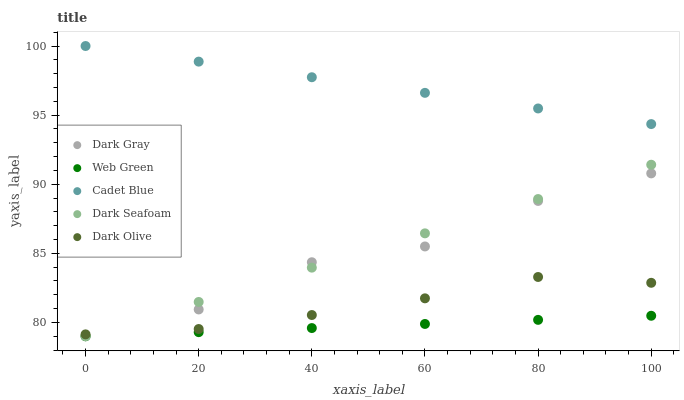Does Web Green have the minimum area under the curve?
Answer yes or no. Yes. Does Cadet Blue have the maximum area under the curve?
Answer yes or no. Yes. Does Dark Seafoam have the minimum area under the curve?
Answer yes or no. No. Does Dark Seafoam have the maximum area under the curve?
Answer yes or no. No. Is Dark Seafoam the smoothest?
Answer yes or no. Yes. Is Dark Gray the roughest?
Answer yes or no. Yes. Is Cadet Blue the smoothest?
Answer yes or no. No. Is Cadet Blue the roughest?
Answer yes or no. No. Does Dark Gray have the lowest value?
Answer yes or no. Yes. Does Cadet Blue have the lowest value?
Answer yes or no. No. Does Cadet Blue have the highest value?
Answer yes or no. Yes. Does Dark Seafoam have the highest value?
Answer yes or no. No. Is Web Green less than Cadet Blue?
Answer yes or no. Yes. Is Cadet Blue greater than Dark Gray?
Answer yes or no. Yes. Does Dark Gray intersect Dark Olive?
Answer yes or no. Yes. Is Dark Gray less than Dark Olive?
Answer yes or no. No. Is Dark Gray greater than Dark Olive?
Answer yes or no. No. Does Web Green intersect Cadet Blue?
Answer yes or no. No. 